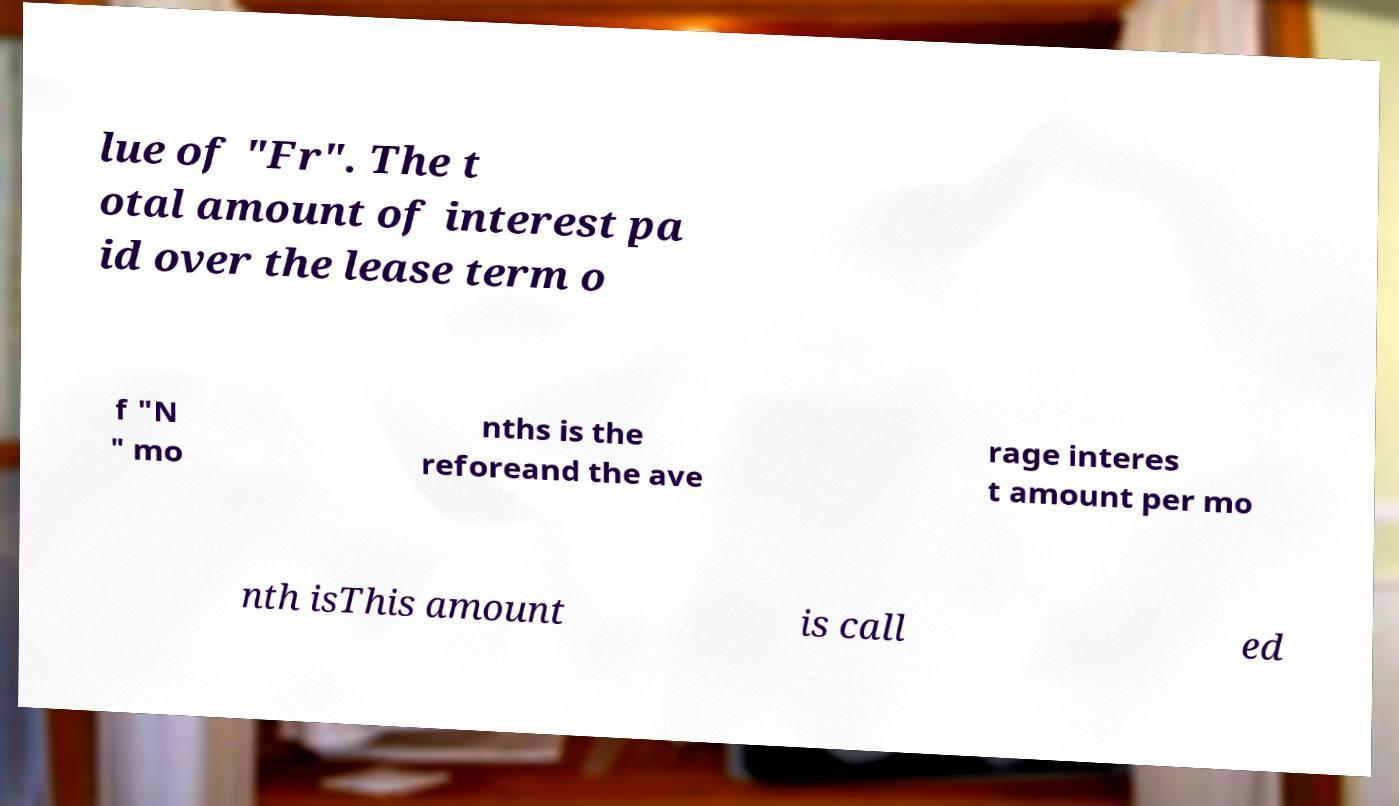I need the written content from this picture converted into text. Can you do that? lue of "Fr". The t otal amount of interest pa id over the lease term o f "N " mo nths is the reforeand the ave rage interes t amount per mo nth isThis amount is call ed 